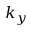Convert formula to latex. <formula><loc_0><loc_0><loc_500><loc_500>k _ { y }</formula> 